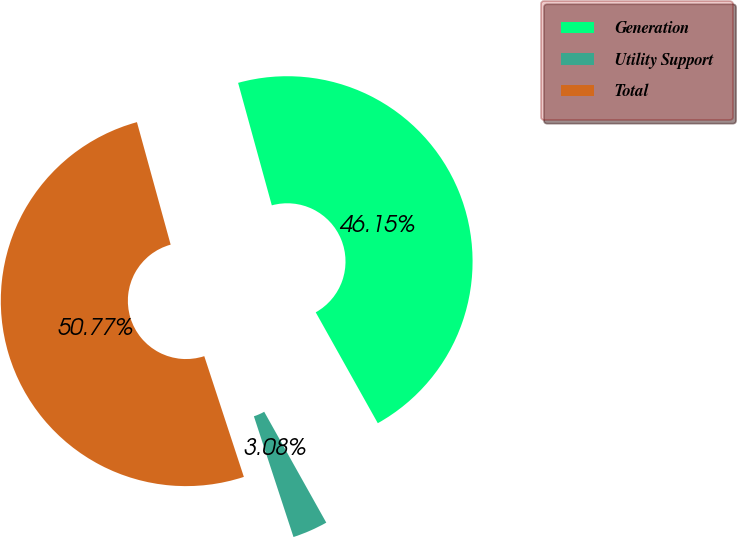Convert chart. <chart><loc_0><loc_0><loc_500><loc_500><pie_chart><fcel>Generation<fcel>Utility Support<fcel>Total<nl><fcel>46.15%<fcel>3.08%<fcel>50.77%<nl></chart> 